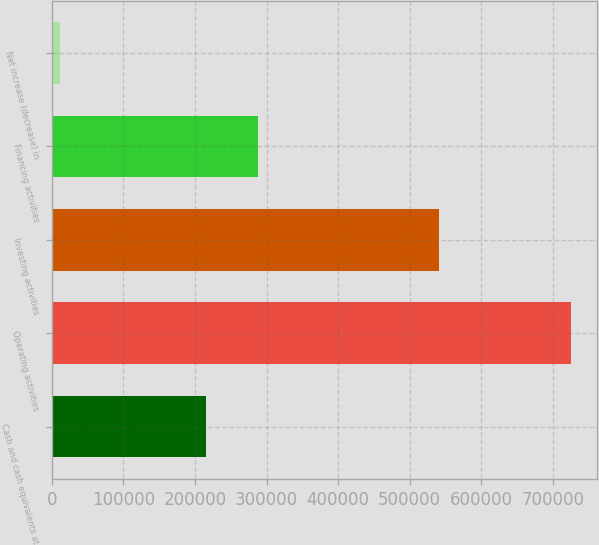Convert chart to OTSL. <chart><loc_0><loc_0><loc_500><loc_500><bar_chart><fcel>Cash and cash equivalents at<fcel>Operating activities<fcel>Investing activities<fcel>Financing activities<fcel>Net increase (decrease) in<nl><fcel>216002<fcel>726130<fcel>541583<fcel>287543<fcel>10713<nl></chart> 